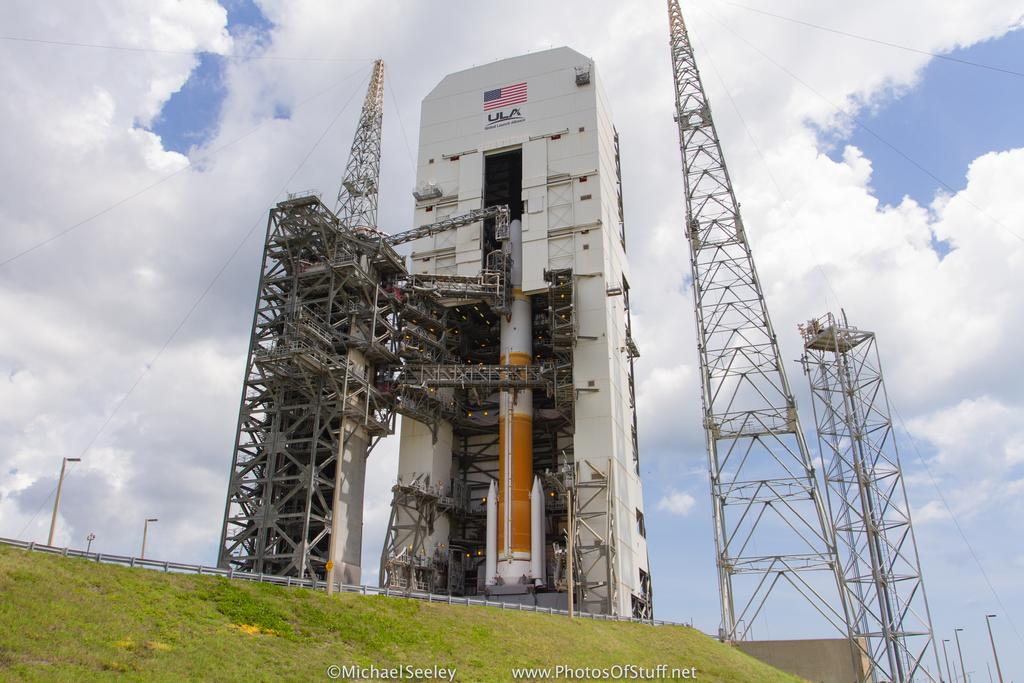<image>
Render a clear and concise summary of the photo. A photo of a rocket housing with copyright by Michael Seeley. 